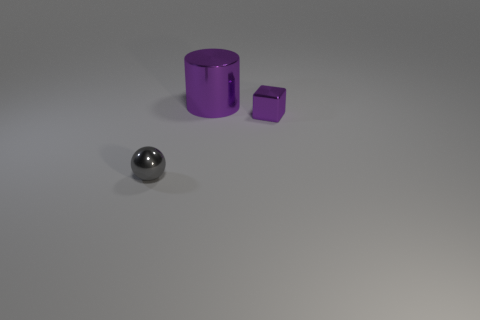Add 1 tiny gray shiny things. How many objects exist? 4 Subtract all cubes. How many objects are left? 2 Subtract 0 yellow cubes. How many objects are left? 3 Subtract all large green rubber things. Subtract all big purple cylinders. How many objects are left? 2 Add 3 small gray shiny objects. How many small gray shiny objects are left? 4 Add 2 metal cylinders. How many metal cylinders exist? 3 